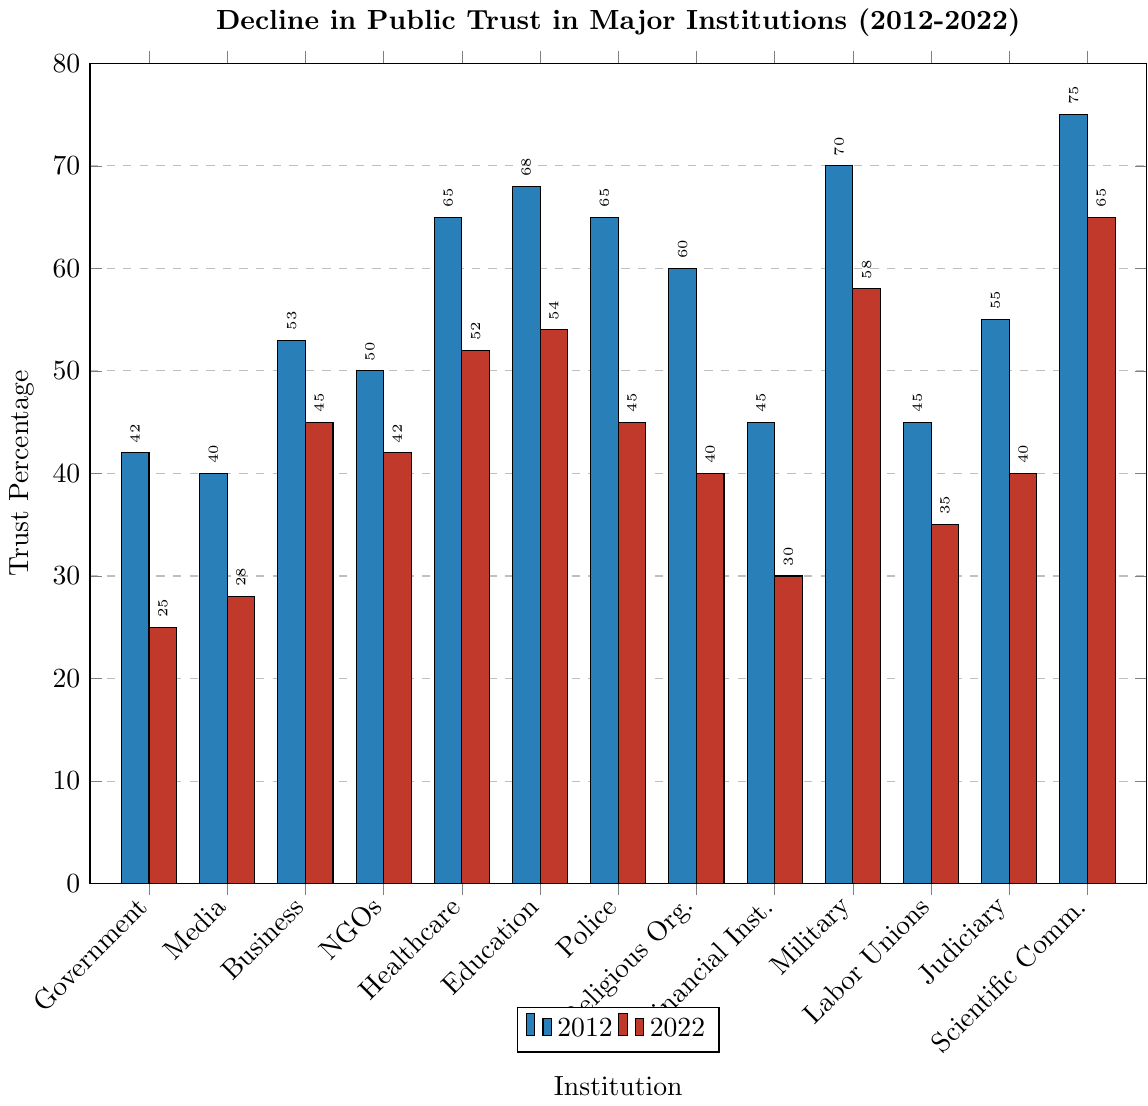Which institution saw the greatest decline in trust from 2012 to 2022? Reviewing the difference in trust percentages between 2012 and 2022 for each institution, the largest difference is seen for the Police, which declined from 65% to 45%, a drop of 20%.
Answer: Police Which institution had the highest trust percentage in 2022? Observing the trust percentages for 2022 across all institutions, the Scientific Community had the highest percentage at 65%.
Answer: Scientific Community What was the change in trust percentage for NGOs from 2012 to 2022? Trust in NGOs decreased from 50% in 2012 to 42% in 2022. The change can be calculated by subtracting 42 from 50.
Answer: 8% Compare the trust percentage in the Military to the trust percentage in Education for the year 2022. In 2022, the Military had a trust percentage of 58% while Education had 54%. Thus, the Military had a higher trust percentage than Education by 4 percentage points.
Answer: Military had 4% higher trust What is the average trust percentage for all institutions in 2022? To calculate the average, sum the trust percentages for all institutions in 2022 and divide by the number of institutions (13). The calculation is: (25 + 28 + 45 + 42 + 52 + 54 + 45 + 40 + 30 + 58 + 35 + 40 + 65) / 13.
Answer: 43.9% Which three institutions had the smallest drop in trust percentages between 2012 and 2022? Calculating the difference in trust percentage for each institution, the three with the smallest declines are the Scientific Community (10%), Military (12%), and Business (8%).
Answer: Scientific Community, Military, Business Which institution maintained the same rank in trust between 2012 and 2022? Observing the order of trust percentages, the Scientific Community remained the highest in trust in both 2012 and 2022, maintaining its rank.
Answer: Scientific Community What is the median trust percentage of institutions in 2022? To find the median, list the 2022 trust percentages in ascending order: 25, 28, 30, 35, 40, 40, 42, 45, 45, 52, 54, 58, 65. The middle value (7th out of 13) is 42%.
Answer: 42% How many institutions had a trust percentage below 50% in 2012 and 2022? In 2012: Government (42%), Media (40%), Financial Institutions (45%), Labor Unions (45%), Judiciary (55%) each had a trust below 50%. In 2022: Government (25%), Media (28%), Religious Organizations (40%), NGOs (42%), Financial Institutions (30%), Labor Unions (35%), Judiciary (40%), Police (45%) had a trust below 50%.
Answer: 5 in 2012, 8 in 2022 